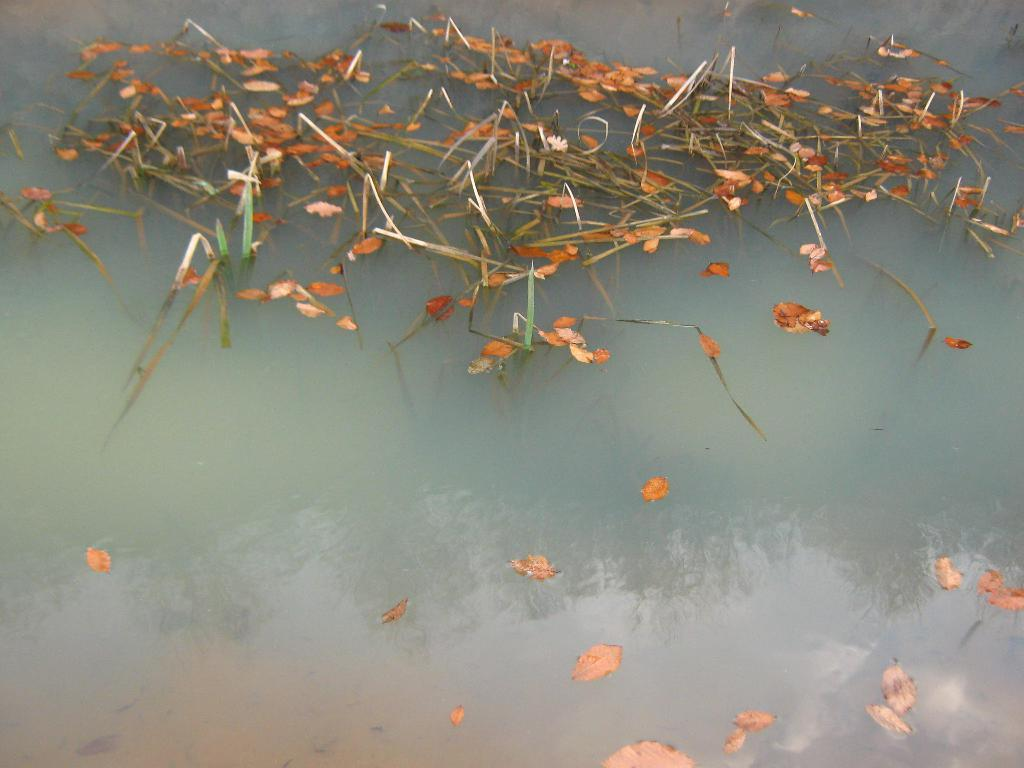What type of natural material is present in the image? There are dry leaves in the image. How are the dry leaves situated in the image? The dry leaves are floating on the water. What type of fruit can be seen growing in the shade in the image? There is no fruit or indication of a growing plant in the image; it features dry leaves floating on water. 